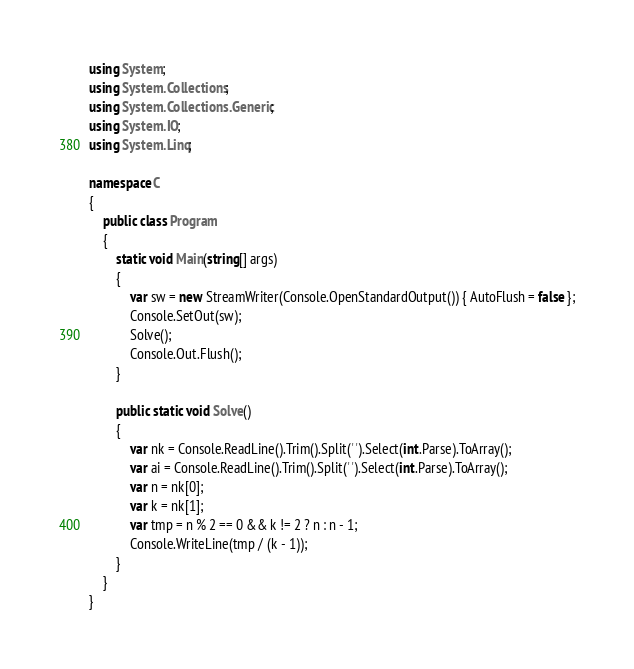<code> <loc_0><loc_0><loc_500><loc_500><_C#_>using System;
using System.Collections;
using System.Collections.Generic;
using System.IO;
using System.Linq;

namespace C
{
    public class Program
    {
        static void Main(string[] args)
        {
            var sw = new StreamWriter(Console.OpenStandardOutput()) { AutoFlush = false };
            Console.SetOut(sw);
            Solve();
            Console.Out.Flush();
        }

        public static void Solve()
        {
            var nk = Console.ReadLine().Trim().Split(' ').Select(int.Parse).ToArray();
            var ai = Console.ReadLine().Trim().Split(' ').Select(int.Parse).ToArray();
            var n = nk[0];
            var k = nk[1];
            var tmp = n % 2 == 0 && k != 2 ? n : n - 1;
            Console.WriteLine(tmp / (k - 1));
        }
    }
}
</code> 